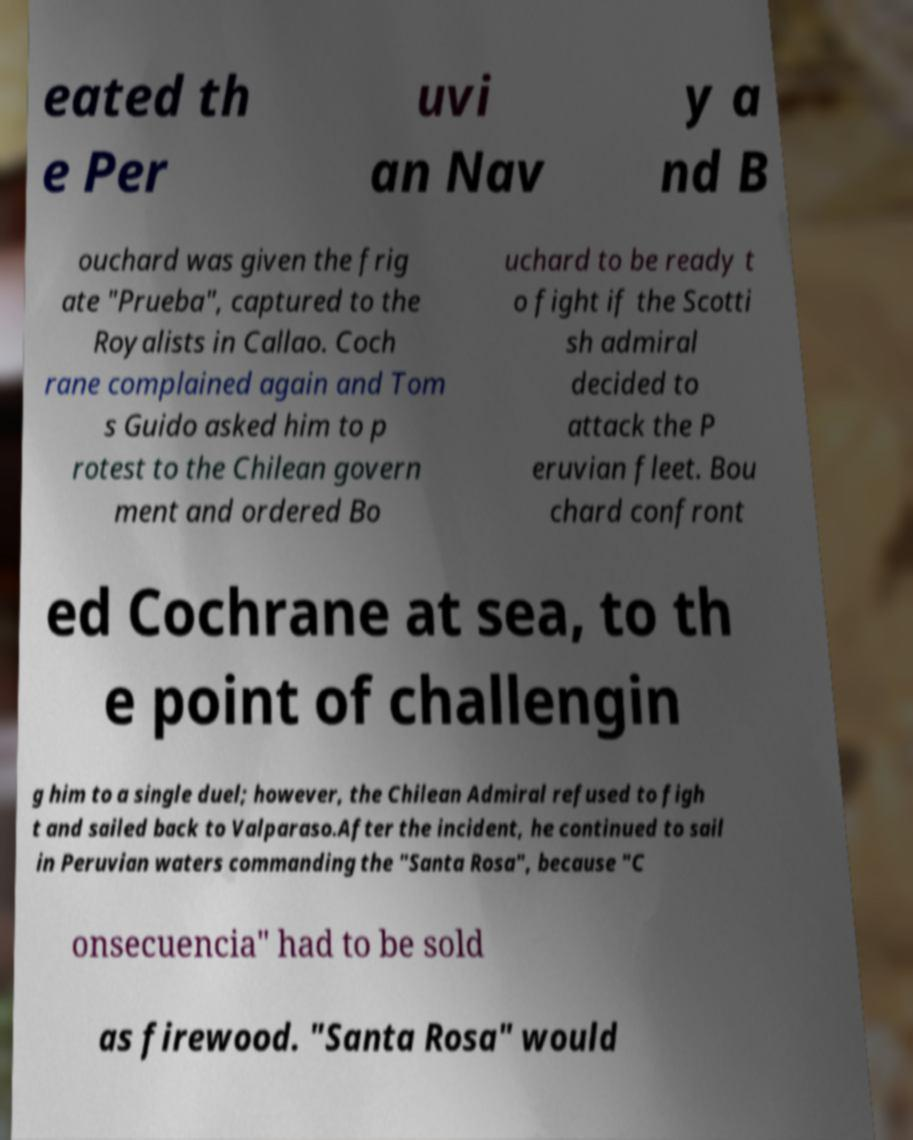There's text embedded in this image that I need extracted. Can you transcribe it verbatim? eated th e Per uvi an Nav y a nd B ouchard was given the frig ate "Prueba", captured to the Royalists in Callao. Coch rane complained again and Tom s Guido asked him to p rotest to the Chilean govern ment and ordered Bo uchard to be ready t o fight if the Scotti sh admiral decided to attack the P eruvian fleet. Bou chard confront ed Cochrane at sea, to th e point of challengin g him to a single duel; however, the Chilean Admiral refused to figh t and sailed back to Valparaso.After the incident, he continued to sail in Peruvian waters commanding the "Santa Rosa", because "C onsecuencia" had to be sold as firewood. "Santa Rosa" would 